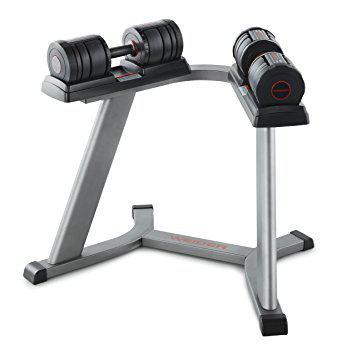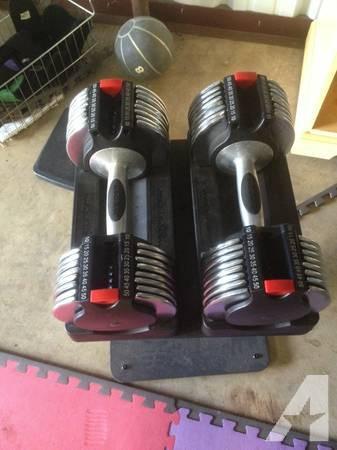The first image is the image on the left, the second image is the image on the right. Evaluate the accuracy of this statement regarding the images: "The left and right image contains the same number of weights sitting on a tower.". Is it true? Answer yes or no. Yes. 